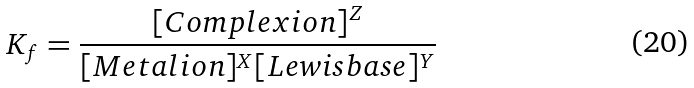<formula> <loc_0><loc_0><loc_500><loc_500>K _ { f } = { \frac { [ { C o m p l e x i o n } ] ^ { Z } } { [ { M e t a l i o n } ] ^ { X } [ { L e w i s b a s e } ] ^ { Y } } }</formula> 